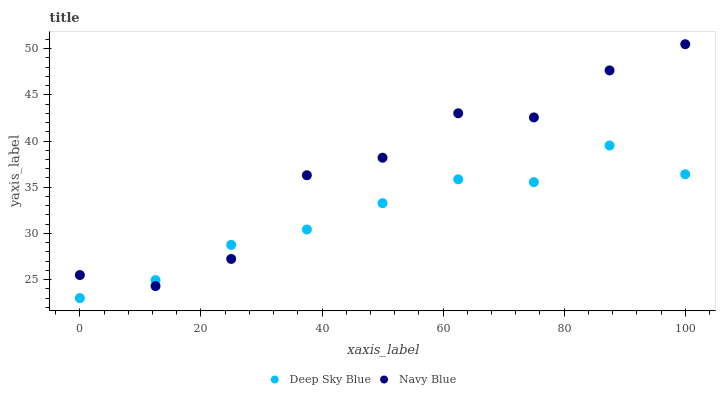Does Deep Sky Blue have the minimum area under the curve?
Answer yes or no. Yes. Does Navy Blue have the maximum area under the curve?
Answer yes or no. Yes. Does Deep Sky Blue have the maximum area under the curve?
Answer yes or no. No. Is Deep Sky Blue the smoothest?
Answer yes or no. Yes. Is Navy Blue the roughest?
Answer yes or no. Yes. Is Deep Sky Blue the roughest?
Answer yes or no. No. Does Deep Sky Blue have the lowest value?
Answer yes or no. Yes. Does Navy Blue have the highest value?
Answer yes or no. Yes. Does Deep Sky Blue have the highest value?
Answer yes or no. No. Does Navy Blue intersect Deep Sky Blue?
Answer yes or no. Yes. Is Navy Blue less than Deep Sky Blue?
Answer yes or no. No. Is Navy Blue greater than Deep Sky Blue?
Answer yes or no. No. 